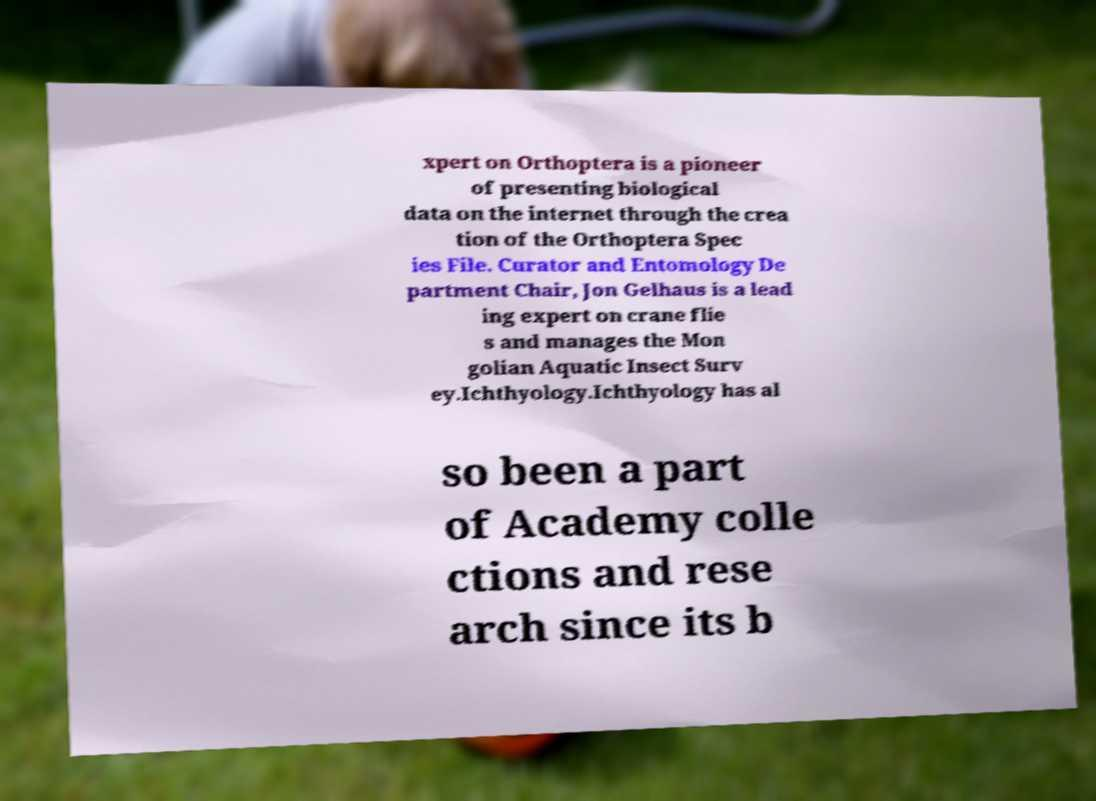I need the written content from this picture converted into text. Can you do that? xpert on Orthoptera is a pioneer of presenting biological data on the internet through the crea tion of the Orthoptera Spec ies File. Curator and Entomology De partment Chair, Jon Gelhaus is a lead ing expert on crane flie s and manages the Mon golian Aquatic Insect Surv ey.Ichthyology.Ichthyology has al so been a part of Academy colle ctions and rese arch since its b 